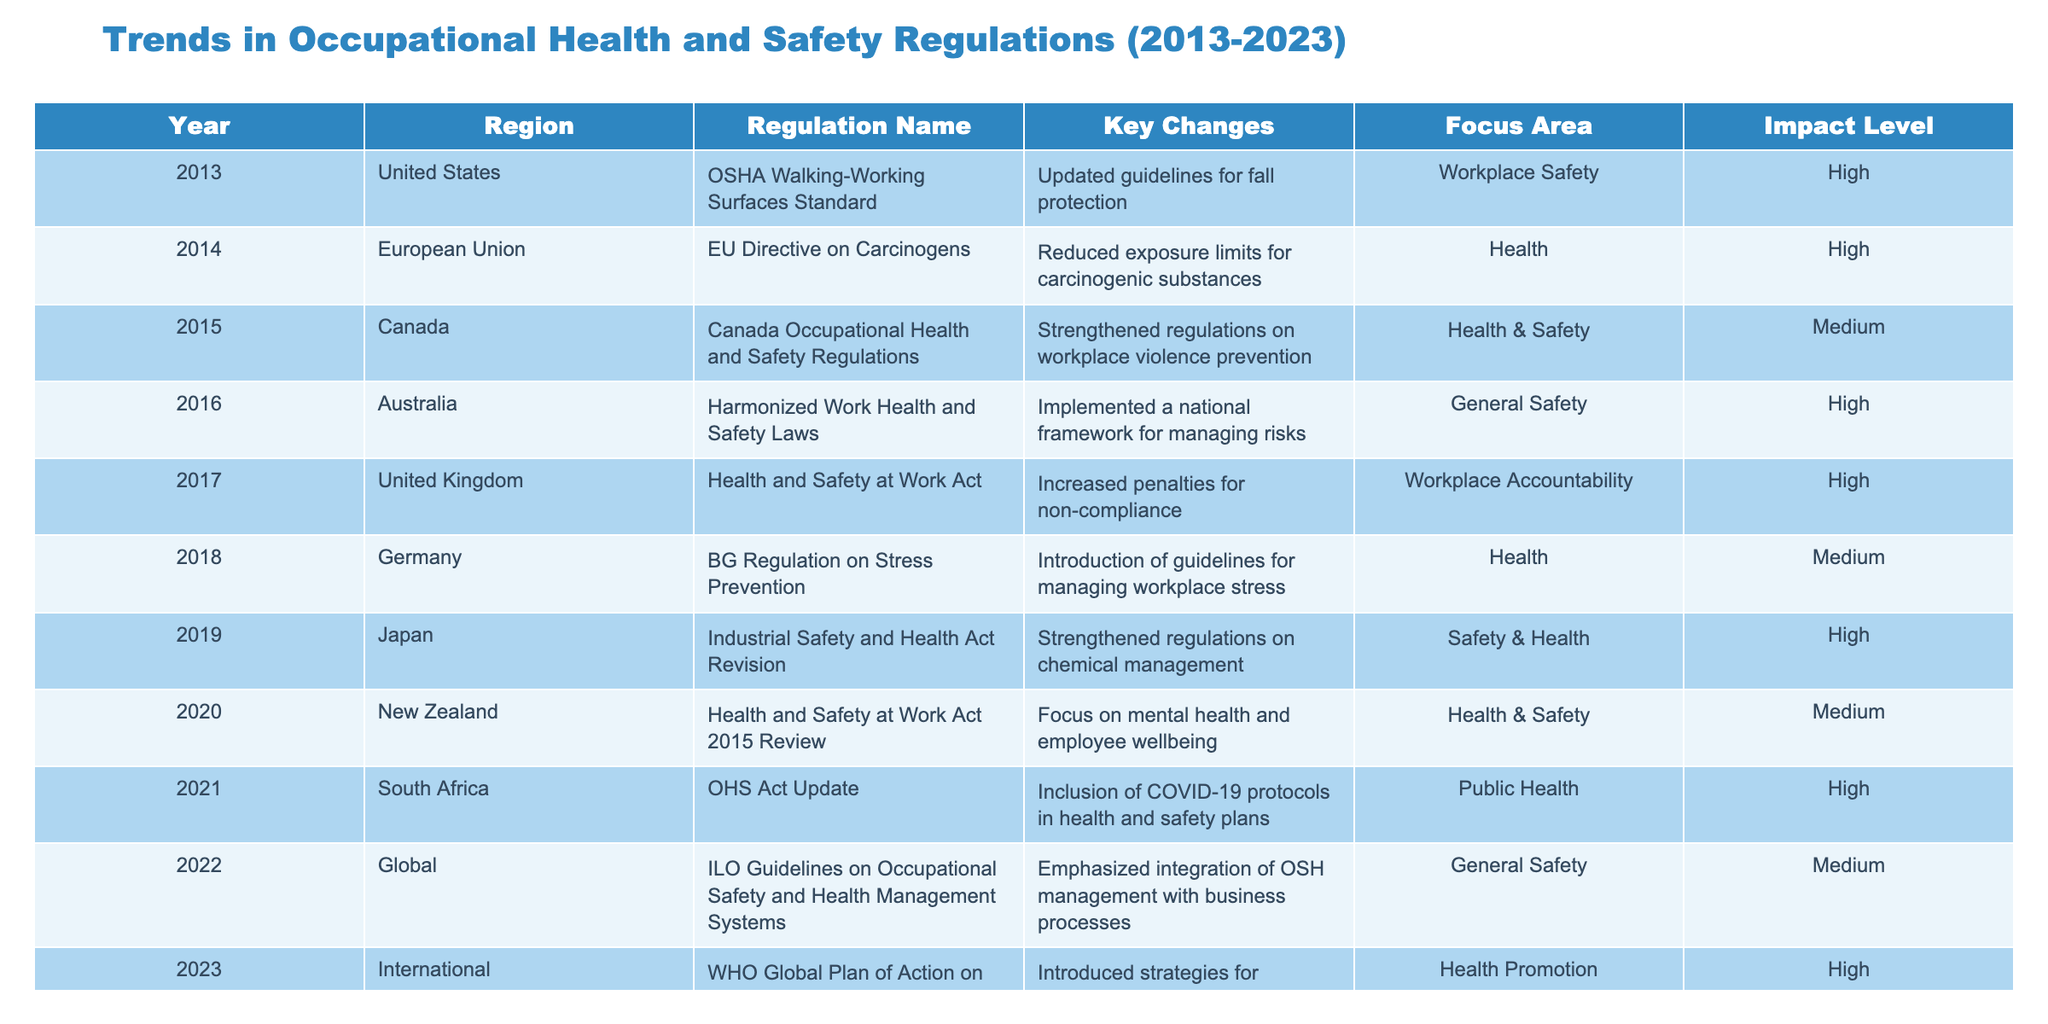What regulation was implemented in the United States in 2013? The table indicates that the regulation implemented in the United States in 2013 was the OSHA Walking-Working Surfaces Standard. This can be found directly under the "Regulation Name" column corresponding to the year 2013.
Answer: OSHA Walking-Working Surfaces Standard Which region updated their regulations in 2014? According to the table, the European Union updated their regulations in 2014. This is evident from the row that lists the year 2014 and shows the respective region.
Answer: European Union What were the key changes in the 2015 Canada Occupational Health and Safety Regulations? The table specifies that the key changes in the 2015 Canada Occupational Health and Safety Regulations were strengthened regulations on workplace violence prevention. This is found in the "Key Changes" column for the year 2015 in Canada.
Answer: Strengthened regulations on workplace violence prevention How many regulations had a high impact level from 2013 to 2023? By reviewing the "Impact Level" column, it shows that there are six regulations with a high impact level: those from 2013, 2014, 2016, 2017, 2019, and 2023. Counting these results gives us a total of six high-impact regulations.
Answer: 6 Was the focus area of the 2021 South Africa OHS Act Update related to public health? Yes, the focus area of the 2021 South Africa OHS Act Update, according to the "Focus Area" column, is indeed related to public health. This aligns with the goal of including COVID-19 protocols in health and safety plans.
Answer: Yes What region and year had a focus on mental health and employee wellbeing? The review of the table reveals that New Zealand focused on mental health and employee well-being in the year 2020. This can be confirmed by locating these keywords in the corresponding columns for that year.
Answer: New Zealand, 2020 Which regulation's key changes emphasized the integration of occupational safety and health management with business processes? The table notes that the ILO Guidelines on Occupational Safety and Health Management Systems in 2022 emphasized the integration of OSH management with business processes as a significant key change. This is retrieved from the relevant entry for the year 2022.
Answer: ILO Guidelines on Occupational Safety and Health Management Systems How many regulations focused on health versus workplace safety from 2013 to 2023? A review of the "Focus Area" column shows that there are four entries focusing on health (European Union in 2014, Australia in 2016, Germany in 2018, and New Zealand in 2020) and two entries focusing on workplace safety (United States in 2013 and the United Kingdom in 2017). Thus, we have a total of four on health and two on workplace safety.
Answer: Health: 4, Workplace Safety: 2 What was the key change reported by Germany in 2018? The table indicates that in 2018, Germany introduced guidelines for managing workplace stress as a key change. This information can be directly checked in the column under "Key Changes" for the year 2018.
Answer: Introduction of guidelines for managing workplace stress 